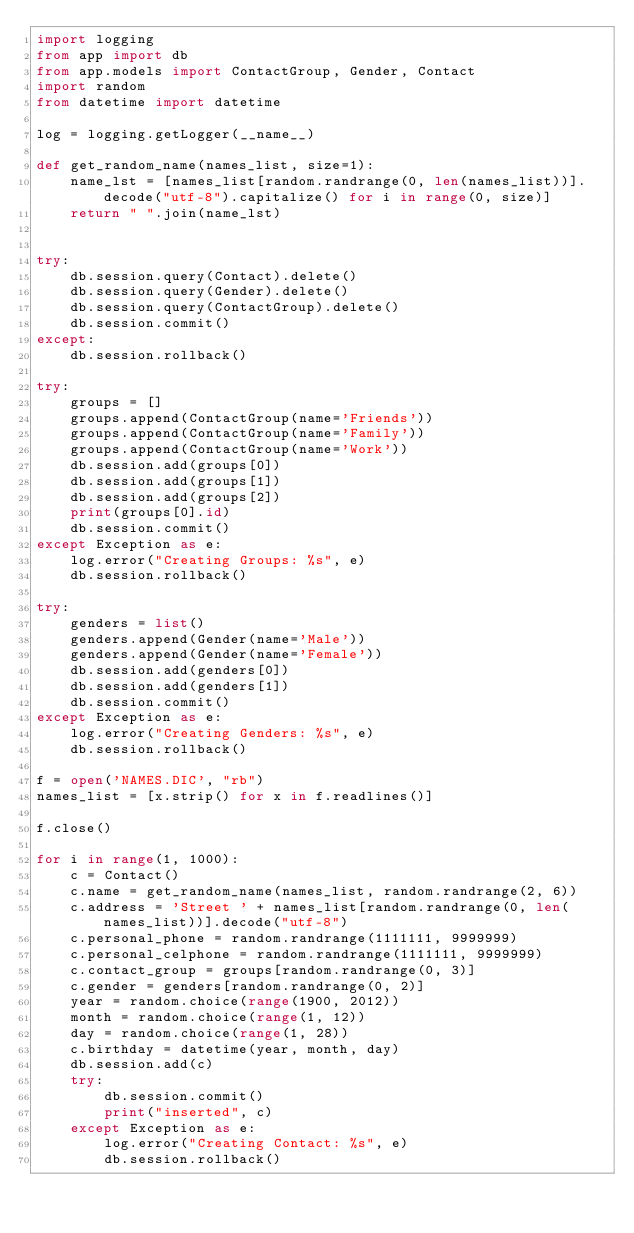Convert code to text. <code><loc_0><loc_0><loc_500><loc_500><_Python_>import logging
from app import db
from app.models import ContactGroup, Gender, Contact
import random
from datetime import datetime

log = logging.getLogger(__name__)

def get_random_name(names_list, size=1):
    name_lst = [names_list[random.randrange(0, len(names_list))].decode("utf-8").capitalize() for i in range(0, size)]
    return " ".join(name_lst)


try:
    db.session.query(Contact).delete()
    db.session.query(Gender).delete()
    db.session.query(ContactGroup).delete()
    db.session.commit()
except:
    db.session.rollback()

try:
    groups = []
    groups.append(ContactGroup(name='Friends'))
    groups.append(ContactGroup(name='Family'))
    groups.append(ContactGroup(name='Work'))
    db.session.add(groups[0])
    db.session.add(groups[1])
    db.session.add(groups[2])
    print(groups[0].id)
    db.session.commit()
except Exception as e:
    log.error("Creating Groups: %s", e)
    db.session.rollback()

try:
    genders = list()
    genders.append(Gender(name='Male'))
    genders.append(Gender(name='Female'))
    db.session.add(genders[0])
    db.session.add(genders[1])
    db.session.commit()
except Exception as e:
    log.error("Creating Genders: %s", e)
    db.session.rollback()

f = open('NAMES.DIC', "rb")
names_list = [x.strip() for x in f.readlines()]

f.close()

for i in range(1, 1000):
    c = Contact()
    c.name = get_random_name(names_list, random.randrange(2, 6))
    c.address = 'Street ' + names_list[random.randrange(0, len(names_list))].decode("utf-8")
    c.personal_phone = random.randrange(1111111, 9999999)
    c.personal_celphone = random.randrange(1111111, 9999999)
    c.contact_group = groups[random.randrange(0, 3)]
    c.gender = genders[random.randrange(0, 2)]
    year = random.choice(range(1900, 2012))
    month = random.choice(range(1, 12))
    day = random.choice(range(1, 28))
    c.birthday = datetime(year, month, day)
    db.session.add(c)
    try:
        db.session.commit()
        print("inserted", c)
    except Exception as e:
        log.error("Creating Contact: %s", e)
        db.session.rollback()
    

</code> 